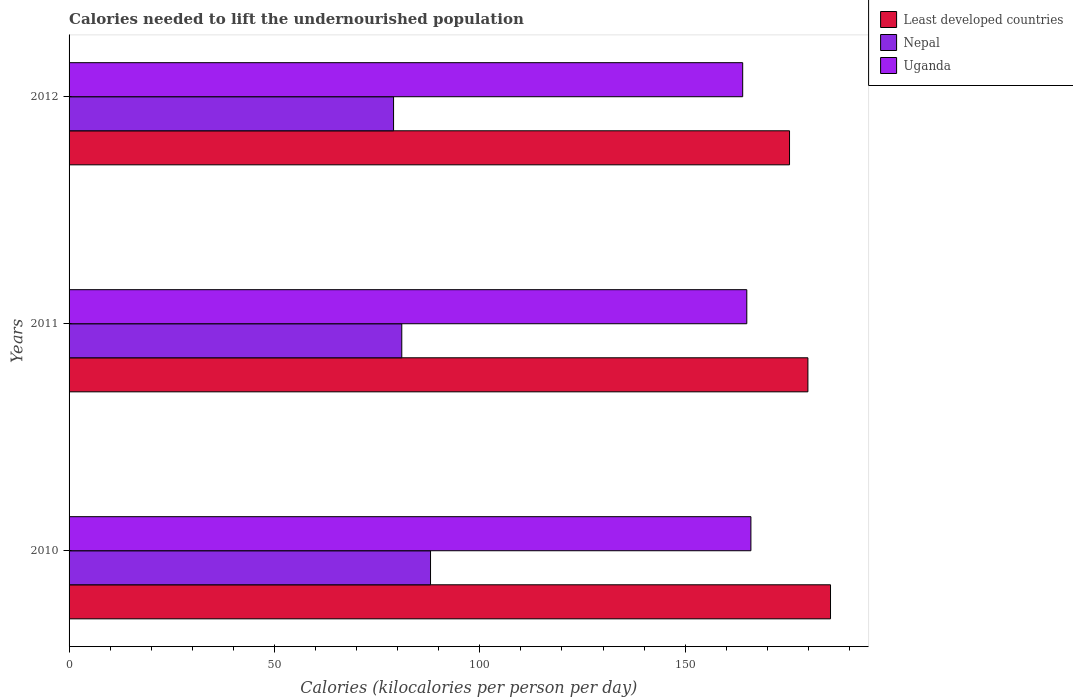How many groups of bars are there?
Keep it short and to the point. 3. How many bars are there on the 3rd tick from the bottom?
Your answer should be compact. 3. What is the label of the 1st group of bars from the top?
Offer a terse response. 2012. What is the total calories needed to lift the undernourished population in Least developed countries in 2010?
Your answer should be very brief. 185.38. Across all years, what is the maximum total calories needed to lift the undernourished population in Least developed countries?
Make the answer very short. 185.38. Across all years, what is the minimum total calories needed to lift the undernourished population in Nepal?
Keep it short and to the point. 79. In which year was the total calories needed to lift the undernourished population in Nepal maximum?
Your response must be concise. 2010. What is the total total calories needed to lift the undernourished population in Nepal in the graph?
Your answer should be compact. 248. What is the difference between the total calories needed to lift the undernourished population in Uganda in 2011 and that in 2012?
Your answer should be very brief. 1. What is the difference between the total calories needed to lift the undernourished population in Nepal in 2011 and the total calories needed to lift the undernourished population in Least developed countries in 2012?
Make the answer very short. -94.4. What is the average total calories needed to lift the undernourished population in Nepal per year?
Offer a terse response. 82.67. In the year 2011, what is the difference between the total calories needed to lift the undernourished population in Nepal and total calories needed to lift the undernourished population in Uganda?
Provide a short and direct response. -84. In how many years, is the total calories needed to lift the undernourished population in Least developed countries greater than 60 kilocalories?
Your response must be concise. 3. What is the ratio of the total calories needed to lift the undernourished population in Nepal in 2010 to that in 2012?
Provide a short and direct response. 1.11. Is the total calories needed to lift the undernourished population in Least developed countries in 2010 less than that in 2012?
Your answer should be very brief. No. What is the difference between the highest and the second highest total calories needed to lift the undernourished population in Nepal?
Your answer should be very brief. 7. What is the difference between the highest and the lowest total calories needed to lift the undernourished population in Uganda?
Give a very brief answer. 2. What does the 3rd bar from the top in 2011 represents?
Your response must be concise. Least developed countries. What does the 1st bar from the bottom in 2011 represents?
Ensure brevity in your answer.  Least developed countries. Are all the bars in the graph horizontal?
Provide a succinct answer. Yes. How many years are there in the graph?
Make the answer very short. 3. What is the difference between two consecutive major ticks on the X-axis?
Your answer should be very brief. 50. Are the values on the major ticks of X-axis written in scientific E-notation?
Your answer should be compact. No. Does the graph contain any zero values?
Provide a succinct answer. No. Where does the legend appear in the graph?
Give a very brief answer. Top right. How are the legend labels stacked?
Give a very brief answer. Vertical. What is the title of the graph?
Provide a short and direct response. Calories needed to lift the undernourished population. Does "Netherlands" appear as one of the legend labels in the graph?
Your answer should be very brief. No. What is the label or title of the X-axis?
Your response must be concise. Calories (kilocalories per person per day). What is the Calories (kilocalories per person per day) in Least developed countries in 2010?
Ensure brevity in your answer.  185.38. What is the Calories (kilocalories per person per day) in Nepal in 2010?
Your answer should be compact. 88. What is the Calories (kilocalories per person per day) in Uganda in 2010?
Keep it short and to the point. 166. What is the Calories (kilocalories per person per day) of Least developed countries in 2011?
Your response must be concise. 179.88. What is the Calories (kilocalories per person per day) in Uganda in 2011?
Provide a succinct answer. 165. What is the Calories (kilocalories per person per day) of Least developed countries in 2012?
Offer a terse response. 175.4. What is the Calories (kilocalories per person per day) in Nepal in 2012?
Provide a short and direct response. 79. What is the Calories (kilocalories per person per day) in Uganda in 2012?
Give a very brief answer. 164. Across all years, what is the maximum Calories (kilocalories per person per day) in Least developed countries?
Make the answer very short. 185.38. Across all years, what is the maximum Calories (kilocalories per person per day) of Nepal?
Your answer should be compact. 88. Across all years, what is the maximum Calories (kilocalories per person per day) in Uganda?
Offer a very short reply. 166. Across all years, what is the minimum Calories (kilocalories per person per day) in Least developed countries?
Your answer should be compact. 175.4. Across all years, what is the minimum Calories (kilocalories per person per day) in Nepal?
Keep it short and to the point. 79. Across all years, what is the minimum Calories (kilocalories per person per day) of Uganda?
Keep it short and to the point. 164. What is the total Calories (kilocalories per person per day) in Least developed countries in the graph?
Offer a terse response. 540.66. What is the total Calories (kilocalories per person per day) in Nepal in the graph?
Your response must be concise. 248. What is the total Calories (kilocalories per person per day) in Uganda in the graph?
Your answer should be compact. 495. What is the difference between the Calories (kilocalories per person per day) in Least developed countries in 2010 and that in 2011?
Provide a succinct answer. 5.5. What is the difference between the Calories (kilocalories per person per day) in Nepal in 2010 and that in 2011?
Your answer should be compact. 7. What is the difference between the Calories (kilocalories per person per day) in Uganda in 2010 and that in 2011?
Keep it short and to the point. 1. What is the difference between the Calories (kilocalories per person per day) of Least developed countries in 2010 and that in 2012?
Keep it short and to the point. 9.98. What is the difference between the Calories (kilocalories per person per day) in Uganda in 2010 and that in 2012?
Your answer should be very brief. 2. What is the difference between the Calories (kilocalories per person per day) of Least developed countries in 2011 and that in 2012?
Provide a short and direct response. 4.47. What is the difference between the Calories (kilocalories per person per day) in Uganda in 2011 and that in 2012?
Your response must be concise. 1. What is the difference between the Calories (kilocalories per person per day) in Least developed countries in 2010 and the Calories (kilocalories per person per day) in Nepal in 2011?
Give a very brief answer. 104.38. What is the difference between the Calories (kilocalories per person per day) in Least developed countries in 2010 and the Calories (kilocalories per person per day) in Uganda in 2011?
Your response must be concise. 20.38. What is the difference between the Calories (kilocalories per person per day) of Nepal in 2010 and the Calories (kilocalories per person per day) of Uganda in 2011?
Give a very brief answer. -77. What is the difference between the Calories (kilocalories per person per day) in Least developed countries in 2010 and the Calories (kilocalories per person per day) in Nepal in 2012?
Your answer should be compact. 106.38. What is the difference between the Calories (kilocalories per person per day) of Least developed countries in 2010 and the Calories (kilocalories per person per day) of Uganda in 2012?
Your response must be concise. 21.38. What is the difference between the Calories (kilocalories per person per day) in Nepal in 2010 and the Calories (kilocalories per person per day) in Uganda in 2012?
Provide a short and direct response. -76. What is the difference between the Calories (kilocalories per person per day) in Least developed countries in 2011 and the Calories (kilocalories per person per day) in Nepal in 2012?
Your response must be concise. 100.88. What is the difference between the Calories (kilocalories per person per day) in Least developed countries in 2011 and the Calories (kilocalories per person per day) in Uganda in 2012?
Offer a very short reply. 15.88. What is the difference between the Calories (kilocalories per person per day) of Nepal in 2011 and the Calories (kilocalories per person per day) of Uganda in 2012?
Provide a short and direct response. -83. What is the average Calories (kilocalories per person per day) in Least developed countries per year?
Ensure brevity in your answer.  180.22. What is the average Calories (kilocalories per person per day) in Nepal per year?
Provide a short and direct response. 82.67. What is the average Calories (kilocalories per person per day) of Uganda per year?
Keep it short and to the point. 165. In the year 2010, what is the difference between the Calories (kilocalories per person per day) in Least developed countries and Calories (kilocalories per person per day) in Nepal?
Provide a succinct answer. 97.38. In the year 2010, what is the difference between the Calories (kilocalories per person per day) of Least developed countries and Calories (kilocalories per person per day) of Uganda?
Your response must be concise. 19.38. In the year 2010, what is the difference between the Calories (kilocalories per person per day) in Nepal and Calories (kilocalories per person per day) in Uganda?
Offer a very short reply. -78. In the year 2011, what is the difference between the Calories (kilocalories per person per day) of Least developed countries and Calories (kilocalories per person per day) of Nepal?
Provide a short and direct response. 98.88. In the year 2011, what is the difference between the Calories (kilocalories per person per day) of Least developed countries and Calories (kilocalories per person per day) of Uganda?
Make the answer very short. 14.88. In the year 2011, what is the difference between the Calories (kilocalories per person per day) of Nepal and Calories (kilocalories per person per day) of Uganda?
Keep it short and to the point. -84. In the year 2012, what is the difference between the Calories (kilocalories per person per day) of Least developed countries and Calories (kilocalories per person per day) of Nepal?
Your answer should be very brief. 96.4. In the year 2012, what is the difference between the Calories (kilocalories per person per day) of Least developed countries and Calories (kilocalories per person per day) of Uganda?
Your answer should be compact. 11.4. In the year 2012, what is the difference between the Calories (kilocalories per person per day) of Nepal and Calories (kilocalories per person per day) of Uganda?
Give a very brief answer. -85. What is the ratio of the Calories (kilocalories per person per day) of Least developed countries in 2010 to that in 2011?
Provide a succinct answer. 1.03. What is the ratio of the Calories (kilocalories per person per day) of Nepal in 2010 to that in 2011?
Ensure brevity in your answer.  1.09. What is the ratio of the Calories (kilocalories per person per day) in Least developed countries in 2010 to that in 2012?
Make the answer very short. 1.06. What is the ratio of the Calories (kilocalories per person per day) in Nepal in 2010 to that in 2012?
Provide a short and direct response. 1.11. What is the ratio of the Calories (kilocalories per person per day) of Uganda in 2010 to that in 2012?
Give a very brief answer. 1.01. What is the ratio of the Calories (kilocalories per person per day) of Least developed countries in 2011 to that in 2012?
Make the answer very short. 1.03. What is the ratio of the Calories (kilocalories per person per day) in Nepal in 2011 to that in 2012?
Provide a short and direct response. 1.03. What is the ratio of the Calories (kilocalories per person per day) in Uganda in 2011 to that in 2012?
Provide a succinct answer. 1.01. What is the difference between the highest and the second highest Calories (kilocalories per person per day) of Least developed countries?
Offer a very short reply. 5.5. What is the difference between the highest and the second highest Calories (kilocalories per person per day) of Nepal?
Your answer should be very brief. 7. What is the difference between the highest and the second highest Calories (kilocalories per person per day) of Uganda?
Provide a succinct answer. 1. What is the difference between the highest and the lowest Calories (kilocalories per person per day) in Least developed countries?
Offer a very short reply. 9.98. What is the difference between the highest and the lowest Calories (kilocalories per person per day) of Uganda?
Provide a succinct answer. 2. 